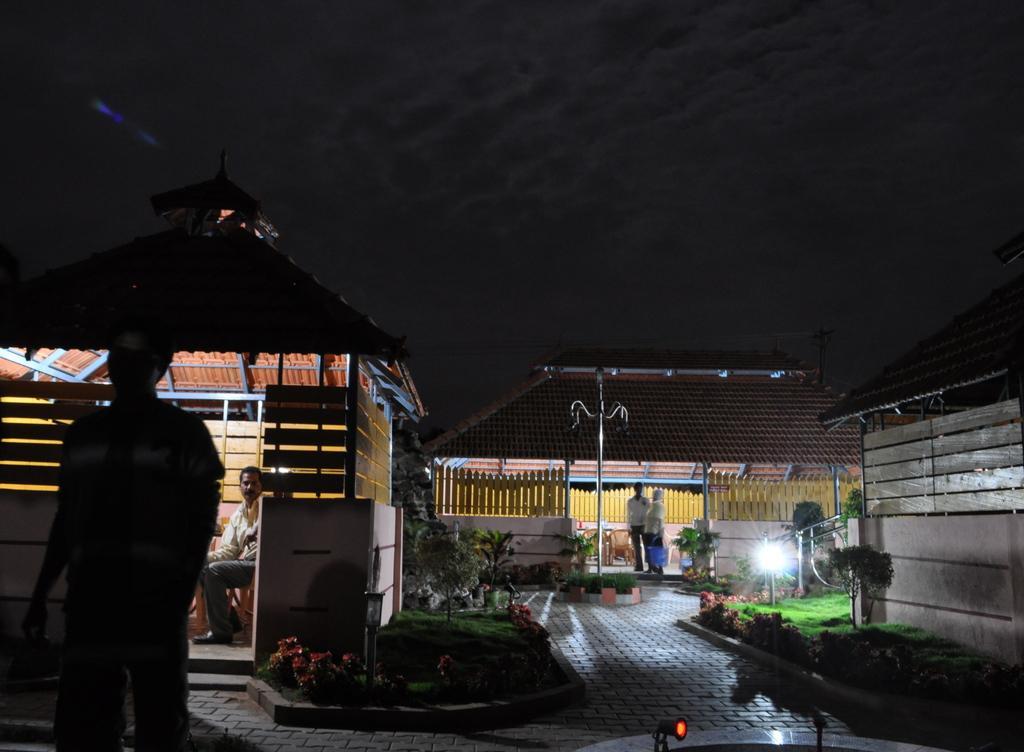How would you summarize this image in a sentence or two? In this image I can see the ground, some grass and few plants on the ground and few houses. I can see few persons standing, a person sitting, few flowers which are red in color and few lights. In the background I can see the sky. 